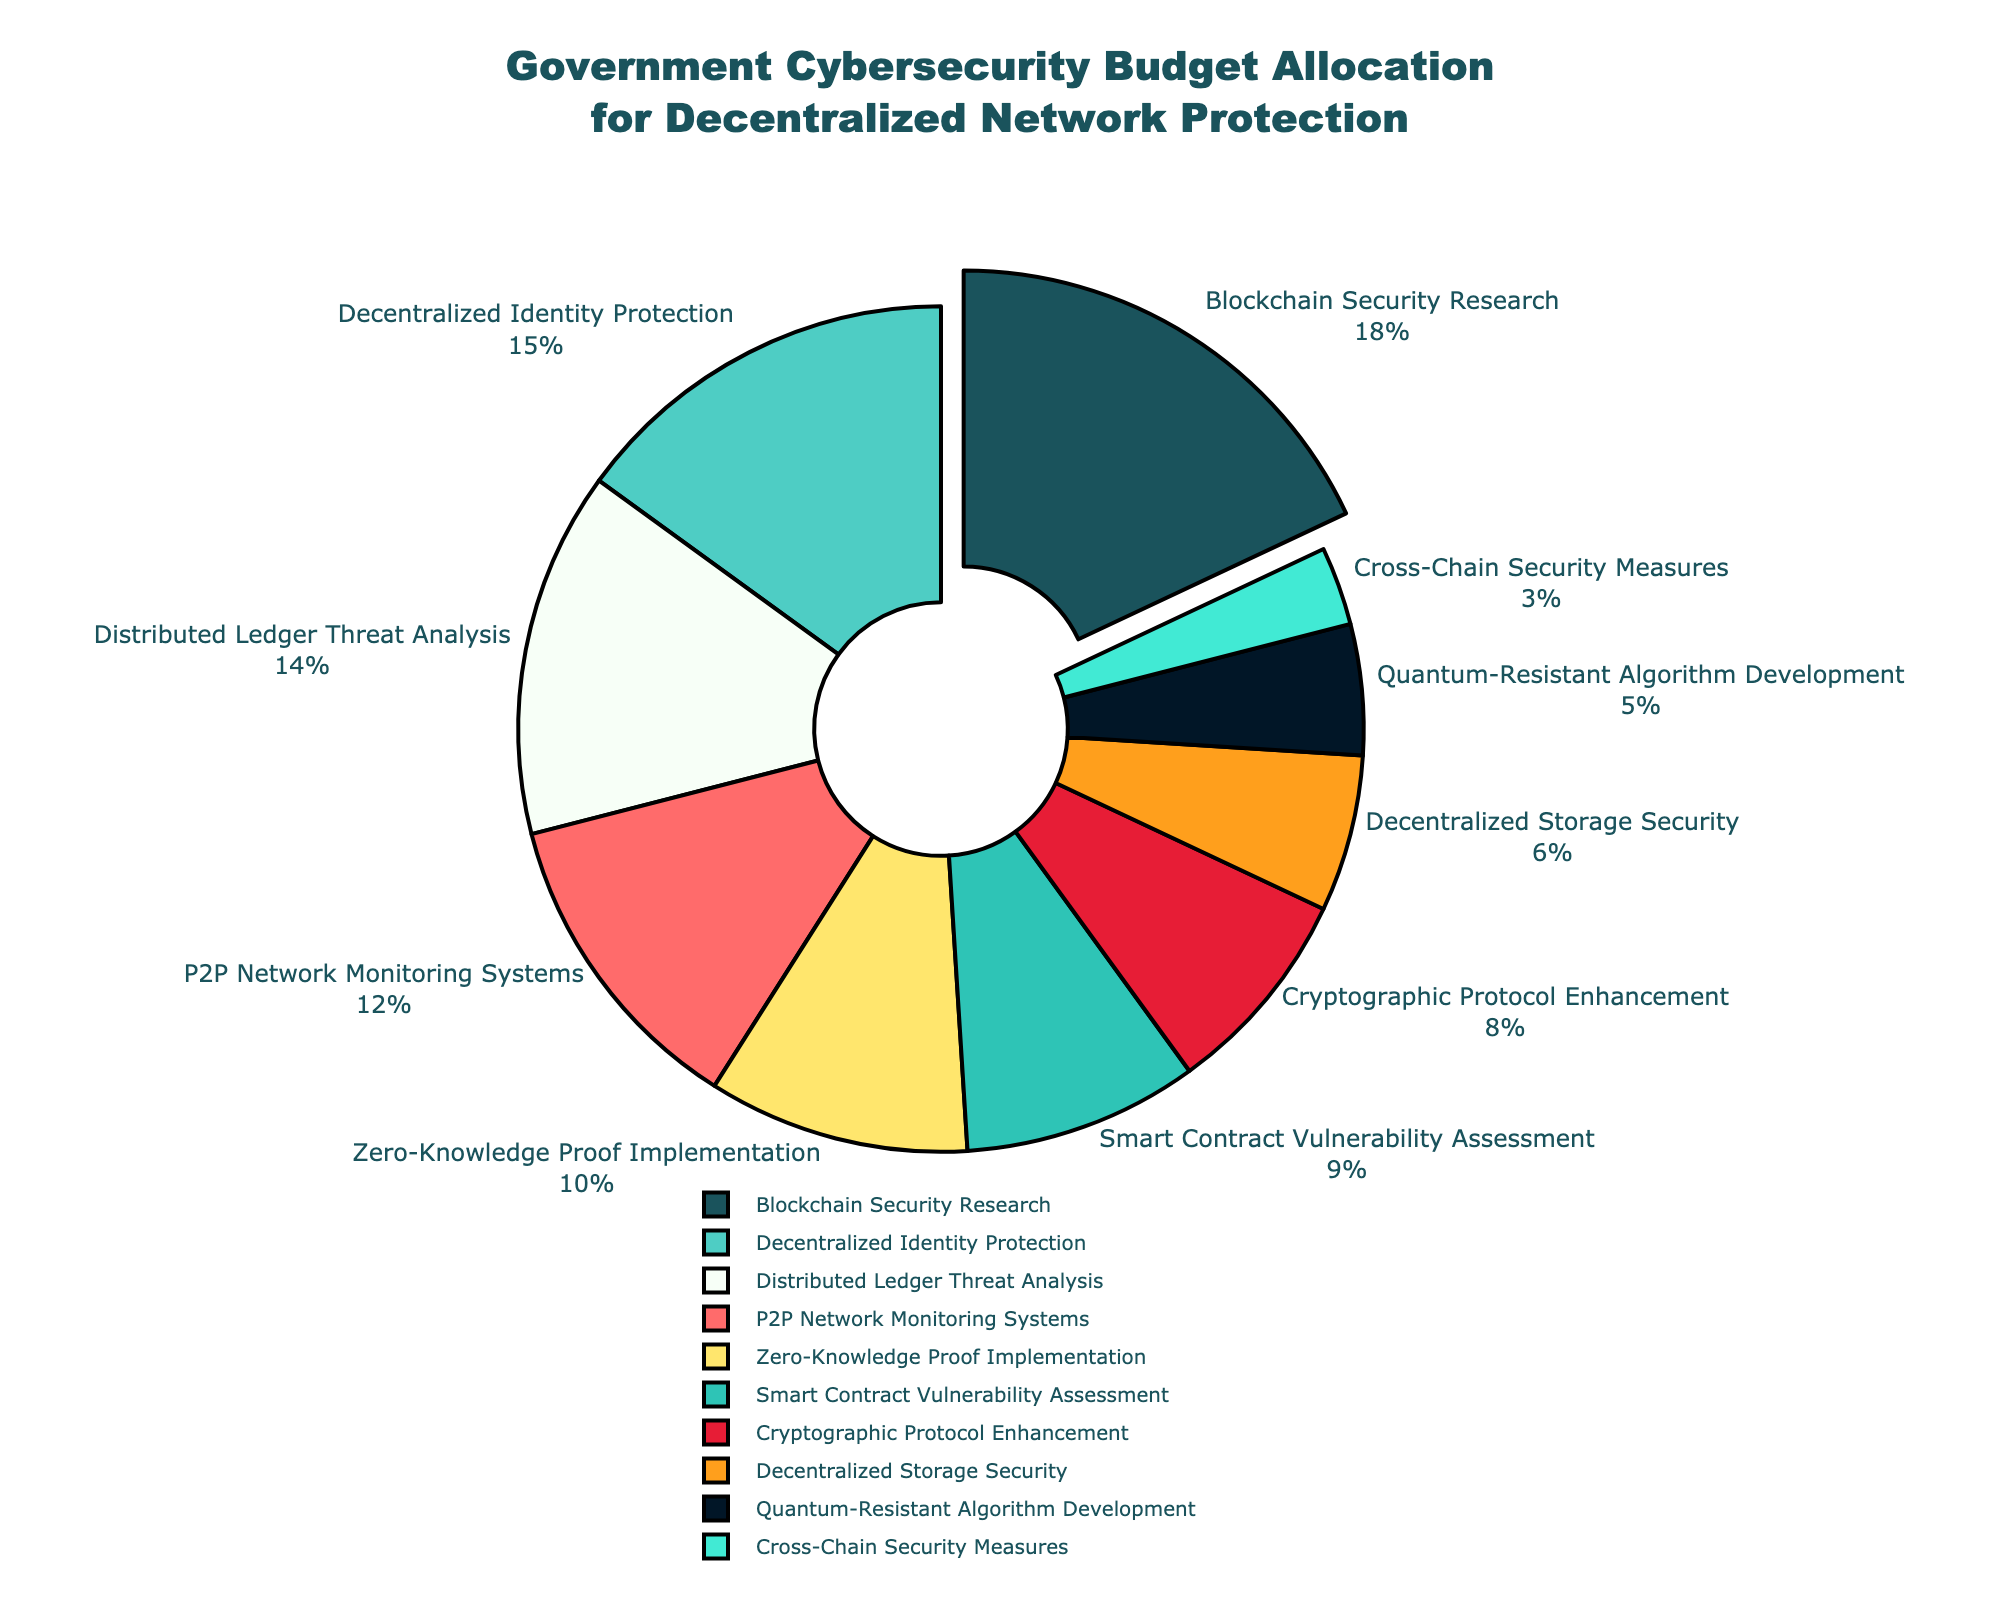What category receives the largest share of the budget allocation? The largest segment of the pie chart is the one that is slightly pulled out from the rest, labeled "Blockchain Security Research," which indicates the corresponding budget allocation.
Answer: Blockchain Security Research Which category receives a smaller share of the budget: P2P Network Monitoring Systems or Quantum-Resistant Algorithm Development? By comparing the sizes of the segments labeled "P2P Network Monitoring Systems" and "Quantum-Resistant Algorithm Development," it is evident that the "Quantum-Resistant Algorithm Development" segment is smaller.
Answer: Quantum-Resistant Algorithm Development What is the total budget allocation percentage for Distributed Ledger Threat Analysis and Smart Contract Vulnerability Assessment combined? Adding the percentage for "Distributed Ledger Threat Analysis" (14%) and "Smart Contract Vulnerability Assessment" (9%) gives 14 + 9 = 23%.
Answer: 23% How much more is allocated to Decentralized Identity Protection than to Decentralized Storage Security? The budget allocation for "Decentralized Identity Protection" is 15%, and for "Decentralized Storage Security" is 6%. The difference is 15 - 6 = 9%.
Answer: 9% What is the average budget allocation for Cross-Chain Security Measures and Zero-Knowledge Proof Implementation? The budget allocation percentages for "Cross-Chain Security Measures" (3%) and "Zero-Knowledge Proof Implementation" (10%) sum up to 3 + 10 = 13%. The average is then 13 / 2 = 6.5%.
Answer: 6.5% Which category receives the second-largest share of the budget, and what is its percentage? The second-largest slice of the pie chart appears to be labeled "Decentralized Identity Protection," which has a budget allocation of 15%.
Answer: Decentralized Identity Protection, 15% What is the combined budget allocation for all categories focused on cryptographic methods (Cryptographic Protocol Enhancement, Zero-Knowledge Proof Implementation, Quantum-Resistant Algorithm Development)? Adding the budget allocations for "Cryptographic Protocol Enhancement" (8%), "Zero-Knowledge Proof Implementation" (10%), and "Quantum-Resistant Algorithm Development" (5%) yields 8 + 10 + 5 = 23%.
Answer: 23% Compare the budget allocations for Smart Contract Vulnerability Assessment and Cross-Chain Security Measures. Which one has a higher allocation, and by how much? The budget allocation for "Smart Contract Vulnerability Assessment" is 9%, and for "Cross-Chain Security Measures" is 3%. The difference is 9 - 3 = 6%.
Answer: Smart Contract Vulnerability Assessment, 6% What is the sum of the budget allocations for P2P Network Monitoring Systems and Decentralized Storage Security? Adding the budget allocations for "P2P Network Monitoring Systems" (12%) and "Decentralized Storage Security" (6%) results in 12 + 6 = 18%.
Answer: 18% How does the budget allocation for Blockchain Security Research compare to the combined allocation of Decentralized Identity Protection and Distributed Ledger Threat Analysis? The budget allocation for "Blockchain Security Research" is 18%. The combined allocation for "Decentralized Identity Protection" (15%) and "Distributed Ledger Threat Analysis" (14%) is 15 + 14 = 29%. 29% is larger by 29 - 18 = 11%.
Answer: The combined allocation for Decentralized Identity Protection and Distributed Ledger Threat Analysis is larger by 11% 